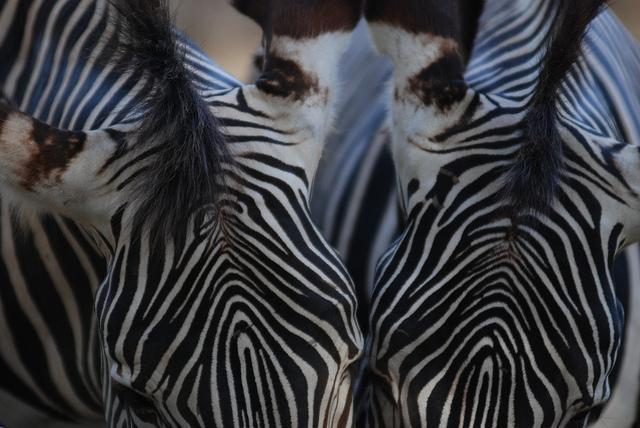How many zebras are in the photo?
Give a very brief answer. 2. 